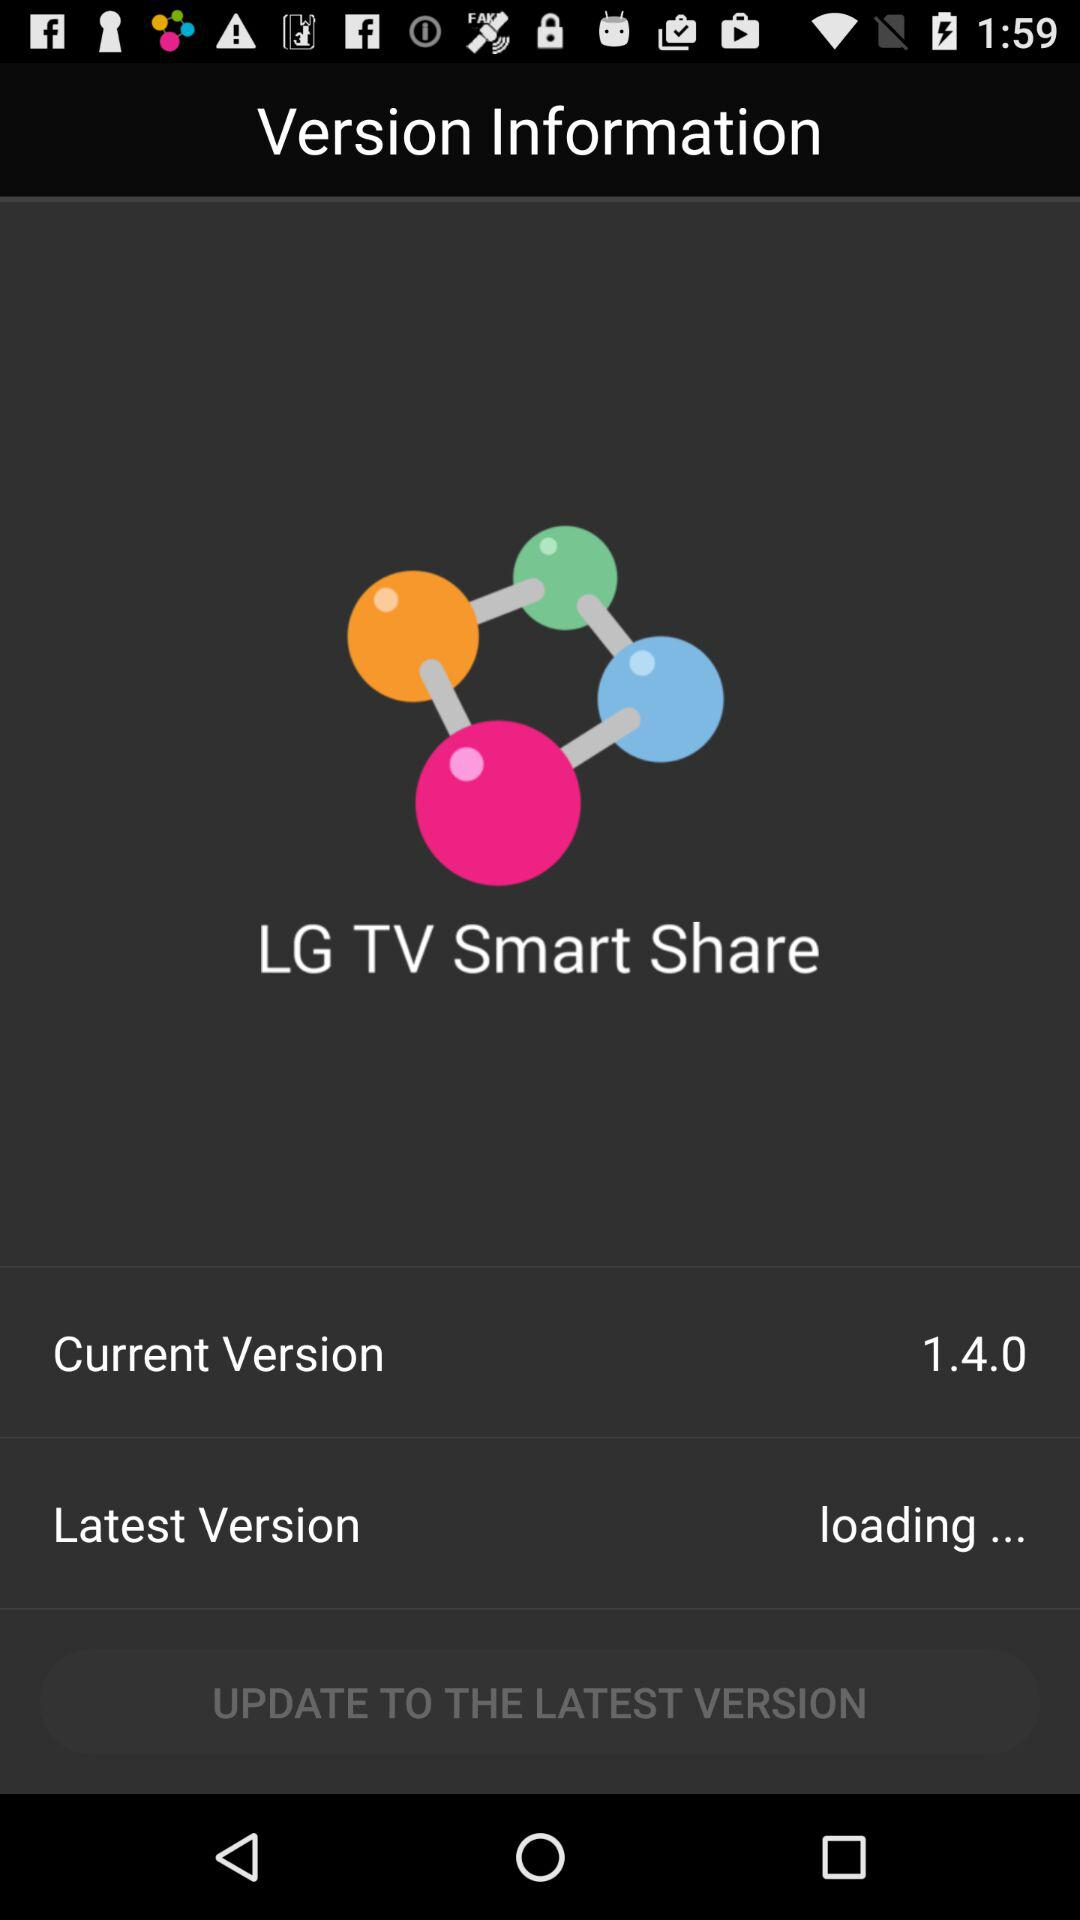What is the current version of LG TV Smart Share?
Answer the question using a single word or phrase. 1.4.0 